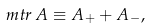Convert formula to latex. <formula><loc_0><loc_0><loc_500><loc_500>m t r \, A \equiv A _ { + } + A _ { - } ,</formula> 